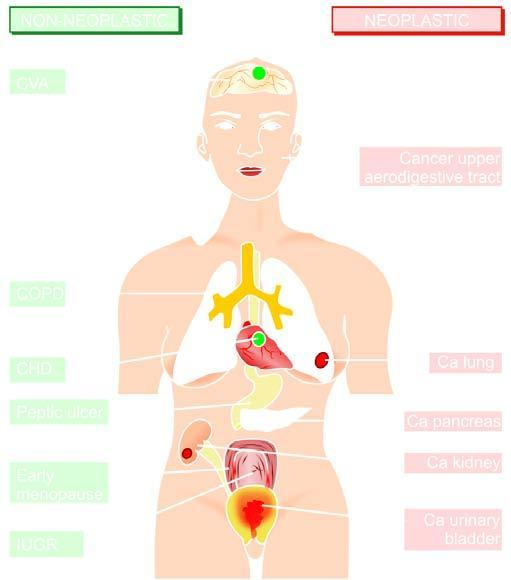what does right side show?
Answer the question using a single word or phrase. Smoking-related neoplastic diseases 